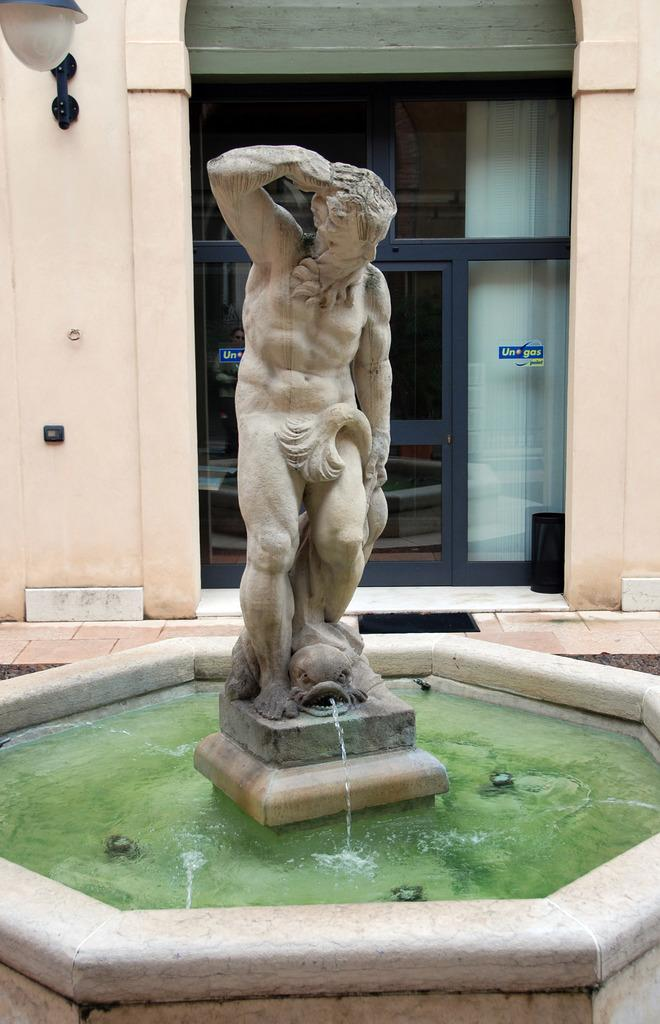What is the main subject of the image? There is a sculpture in the image. What can be seen in the background of the image? There is water visible in the image. What type of structure is present in the image? There is a wall in the image. What architectural feature is visible in the image? There is a glass door in the image. What is the source of illumination in the image? Light is present in the image. How does the turkey use the brake in the image? There is no turkey or brake present in the image. What type of lamp is featured in the image? There is no lamp present in the image. 